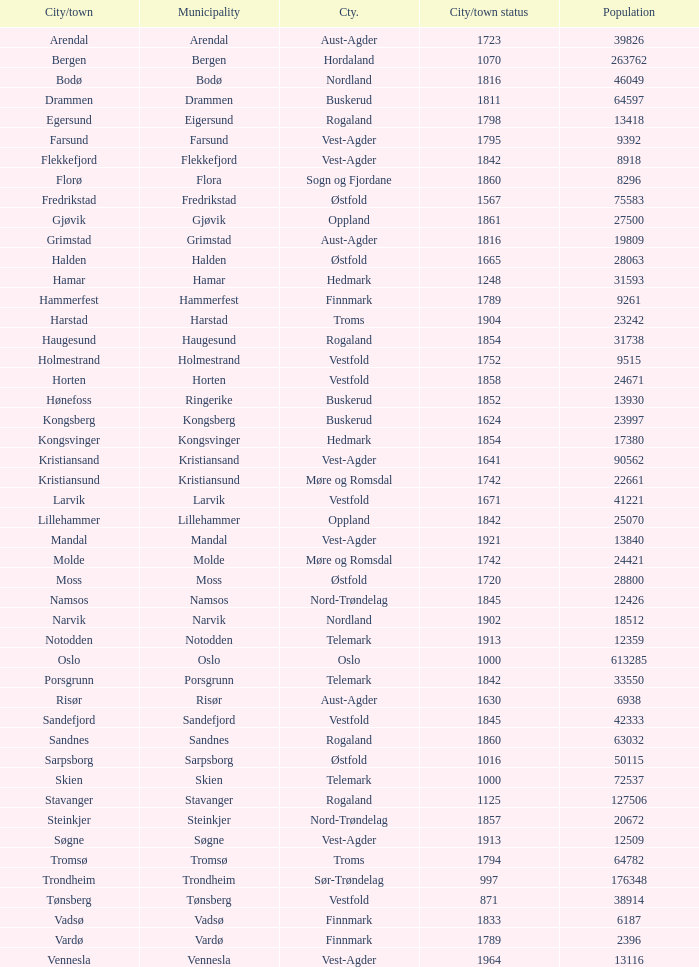0? Hammerfest. Could you help me parse every detail presented in this table? {'header': ['City/town', 'Municipality', 'Cty.', 'City/town status', 'Population'], 'rows': [['Arendal', 'Arendal', 'Aust-Agder', '1723', '39826'], ['Bergen', 'Bergen', 'Hordaland', '1070', '263762'], ['Bodø', 'Bodø', 'Nordland', '1816', '46049'], ['Drammen', 'Drammen', 'Buskerud', '1811', '64597'], ['Egersund', 'Eigersund', 'Rogaland', '1798', '13418'], ['Farsund', 'Farsund', 'Vest-Agder', '1795', '9392'], ['Flekkefjord', 'Flekkefjord', 'Vest-Agder', '1842', '8918'], ['Florø', 'Flora', 'Sogn og Fjordane', '1860', '8296'], ['Fredrikstad', 'Fredrikstad', 'Østfold', '1567', '75583'], ['Gjøvik', 'Gjøvik', 'Oppland', '1861', '27500'], ['Grimstad', 'Grimstad', 'Aust-Agder', '1816', '19809'], ['Halden', 'Halden', 'Østfold', '1665', '28063'], ['Hamar', 'Hamar', 'Hedmark', '1248', '31593'], ['Hammerfest', 'Hammerfest', 'Finnmark', '1789', '9261'], ['Harstad', 'Harstad', 'Troms', '1904', '23242'], ['Haugesund', 'Haugesund', 'Rogaland', '1854', '31738'], ['Holmestrand', 'Holmestrand', 'Vestfold', '1752', '9515'], ['Horten', 'Horten', 'Vestfold', '1858', '24671'], ['Hønefoss', 'Ringerike', 'Buskerud', '1852', '13930'], ['Kongsberg', 'Kongsberg', 'Buskerud', '1624', '23997'], ['Kongsvinger', 'Kongsvinger', 'Hedmark', '1854', '17380'], ['Kristiansand', 'Kristiansand', 'Vest-Agder', '1641', '90562'], ['Kristiansund', 'Kristiansund', 'Møre og Romsdal', '1742', '22661'], ['Larvik', 'Larvik', 'Vestfold', '1671', '41221'], ['Lillehammer', 'Lillehammer', 'Oppland', '1842', '25070'], ['Mandal', 'Mandal', 'Vest-Agder', '1921', '13840'], ['Molde', 'Molde', 'Møre og Romsdal', '1742', '24421'], ['Moss', 'Moss', 'Østfold', '1720', '28800'], ['Namsos', 'Namsos', 'Nord-Trøndelag', '1845', '12426'], ['Narvik', 'Narvik', 'Nordland', '1902', '18512'], ['Notodden', 'Notodden', 'Telemark', '1913', '12359'], ['Oslo', 'Oslo', 'Oslo', '1000', '613285'], ['Porsgrunn', 'Porsgrunn', 'Telemark', '1842', '33550'], ['Risør', 'Risør', 'Aust-Agder', '1630', '6938'], ['Sandefjord', 'Sandefjord', 'Vestfold', '1845', '42333'], ['Sandnes', 'Sandnes', 'Rogaland', '1860', '63032'], ['Sarpsborg', 'Sarpsborg', 'Østfold', '1016', '50115'], ['Skien', 'Skien', 'Telemark', '1000', '72537'], ['Stavanger', 'Stavanger', 'Rogaland', '1125', '127506'], ['Steinkjer', 'Steinkjer', 'Nord-Trøndelag', '1857', '20672'], ['Søgne', 'Søgne', 'Vest-Agder', '1913', '12509'], ['Tromsø', 'Tromsø', 'Troms', '1794', '64782'], ['Trondheim', 'Trondheim', 'Sør-Trøndelag', '997', '176348'], ['Tønsberg', 'Tønsberg', 'Vestfold', '871', '38914'], ['Vadsø', 'Vadsø', 'Finnmark', '1833', '6187'], ['Vardø', 'Vardø', 'Finnmark', '1789', '2396'], ['Vennesla', 'Vennesla', 'Vest-Agder', '1964', '13116']]} 